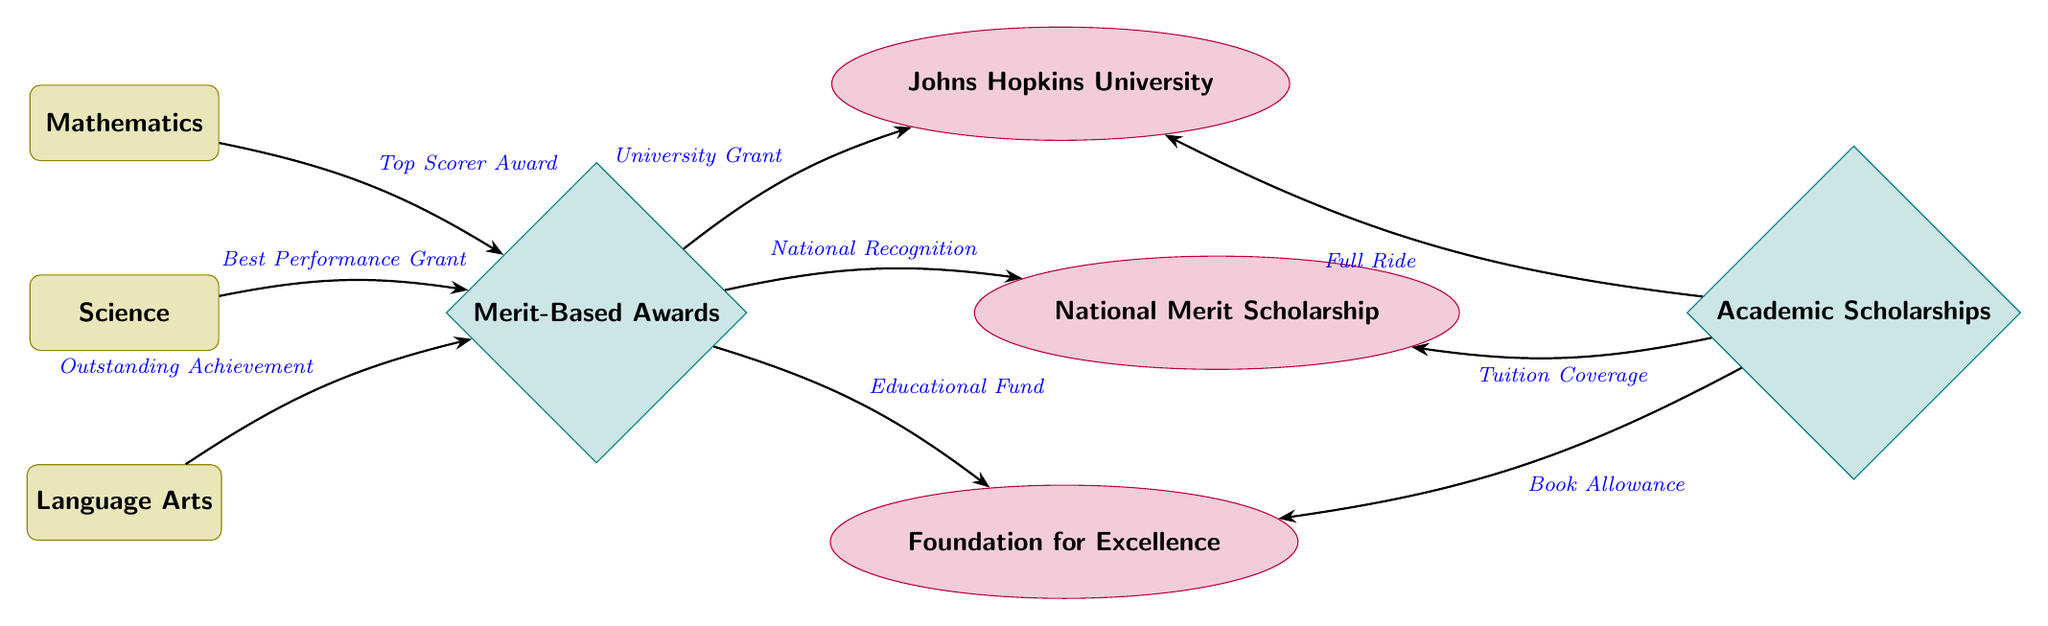What subjects are represented in the diagram? The diagram features three subjects: Mathematics, Science, and Language Arts. These are listed at the top, serving as the starting points for the relationships depicted in the diagram.
Answer: Mathematics, Science, Language Arts How many awards are shown in the diagram? There are two types of awards indicated in the diagram: Merit-Based Awards and Academic Scholarships. Counting these gives a total of two.
Answer: 2 What is the first award connected to Mathematics? The first award linked to Mathematics is the "Top Scorer Award," which shows that high achievers in Mathematics receive recognition that can lead to further scholarships.
Answer: Top Scorer Award Which scholarship is connected to the Merit-Based Awards? The scholarship linked to Merit-Based Awards is the "Johns Hopkins University," which indicates that students receiving merit awards can pursue this opportunity for additional educational funding.
Answer: Johns Hopkins University What type of edge connects Science to the Merit-Based Awards? The edge connecting Science to the Merit-Based Awards is labeled "Best Performance Grant." This shows how top performances in Science can lead to merit-based rewards.
Answer: Best Performance Grant How many total scholarships are connected to the Merit-Based Awards? There are three scholarships connected to the Merit-Based Awards: Johns Hopkins University, National Merit Scholarship, and Foundation for Excellence. Adding these gives three scholarships in total.
Answer: 3 What is the relationship between Academic Scholarships and Johns Hopkins University? The relationship is that Academic Scholarships lead to a "Full Ride" at Johns Hopkins University, meaning that excelling academically can result in complete funding to attend this institution.
Answer: Full Ride Which award is connected to the Language Arts subject? The award connected to Language Arts is the "Outstanding Achievement," indicating recognition for high performance in this specific subject area.
Answer: Outstanding Achievement How does the National Merit Scholarship relate to Merit-Based Awards? The National Merit Scholarship is connected to the Merit-Based Awards via the "National Recognition." This indicates that achieving merit can lead to national-level scholarships for recognition at a broader scale.
Answer: National Recognition 